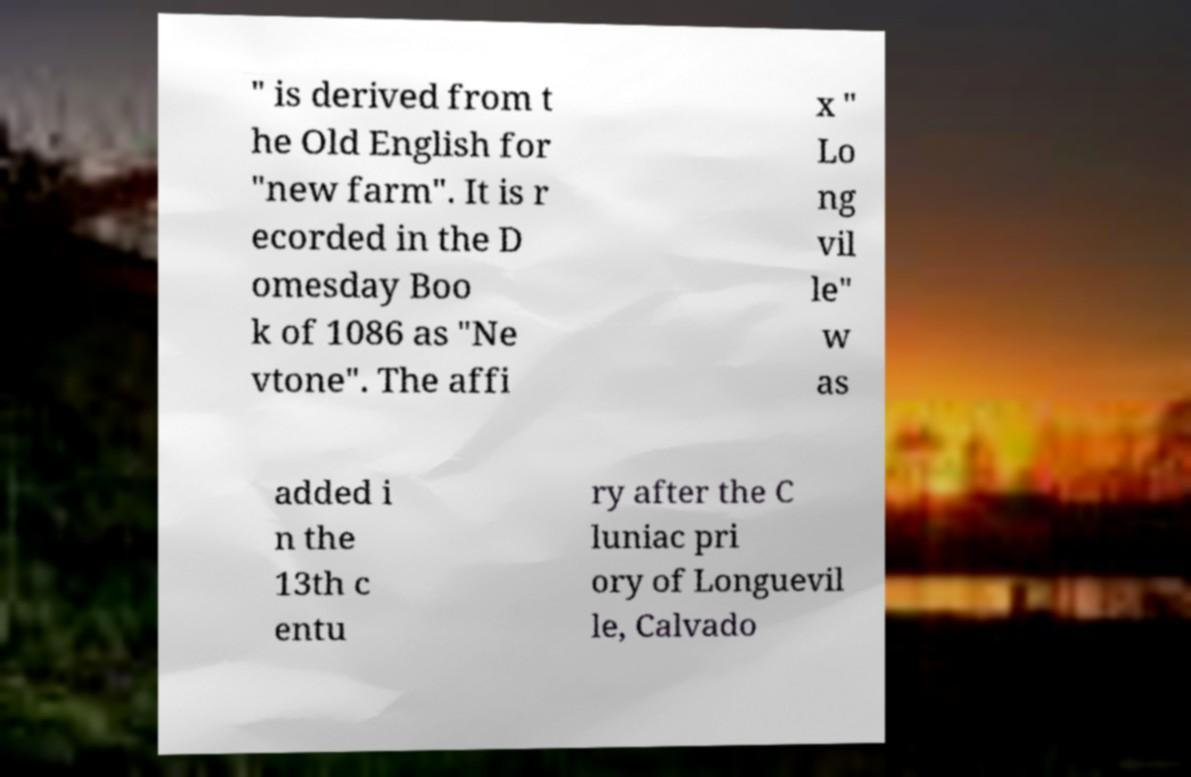For documentation purposes, I need the text within this image transcribed. Could you provide that? " is derived from t he Old English for "new farm". It is r ecorded in the D omesday Boo k of 1086 as "Ne vtone". The affi x " Lo ng vil le" w as added i n the 13th c entu ry after the C luniac pri ory of Longuevil le, Calvado 